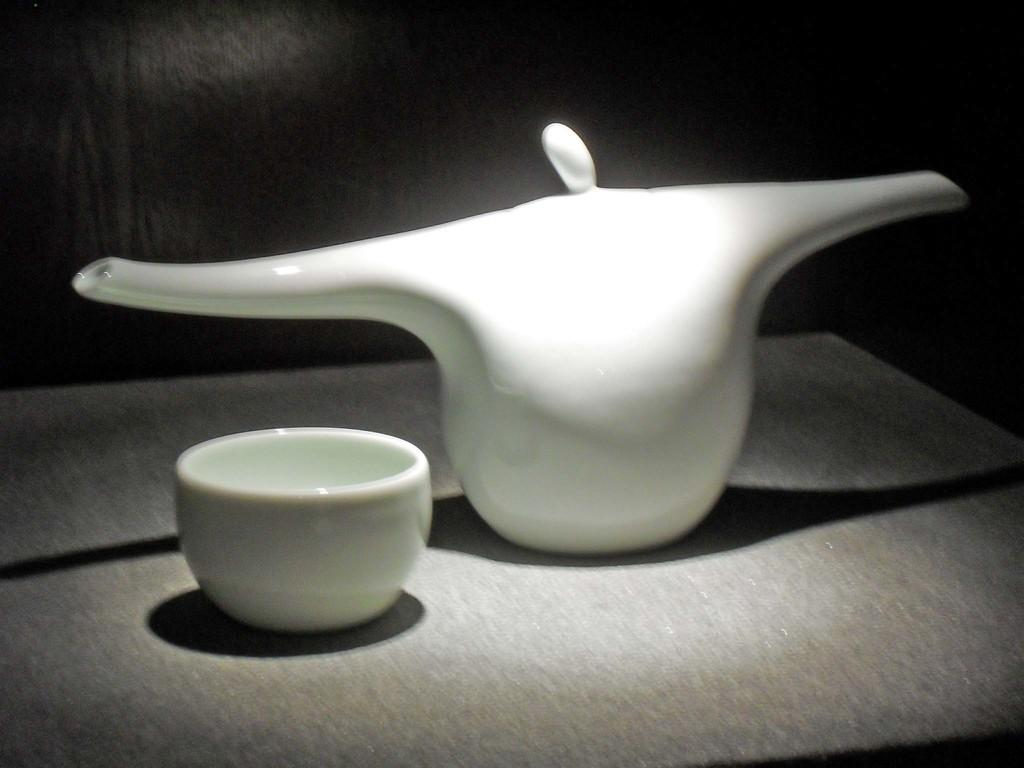What is the main object in the center of the image? There is a flask in the center of the image. What color is the flask? The flask is white in color. Are there any other objects related to the flask in the image? Yes, there is a cup in the image. What type of meat is being cooked in the flask in the image? There is no meat or cooking activity present in the image; it only features a white flask and a cup. 